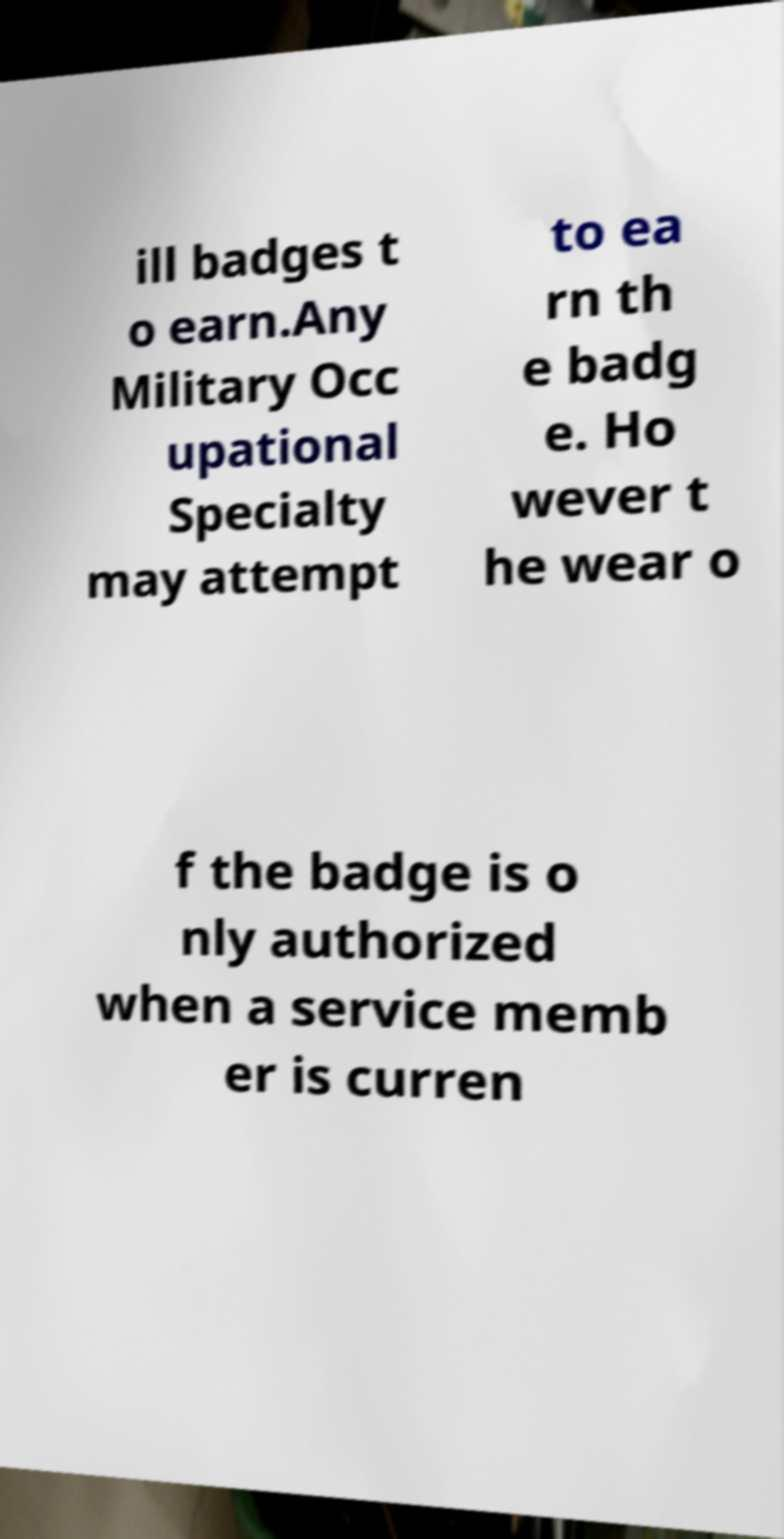Please read and relay the text visible in this image. What does it say? ill badges t o earn.Any Military Occ upational Specialty may attempt to ea rn th e badg e. Ho wever t he wear o f the badge is o nly authorized when a service memb er is curren 